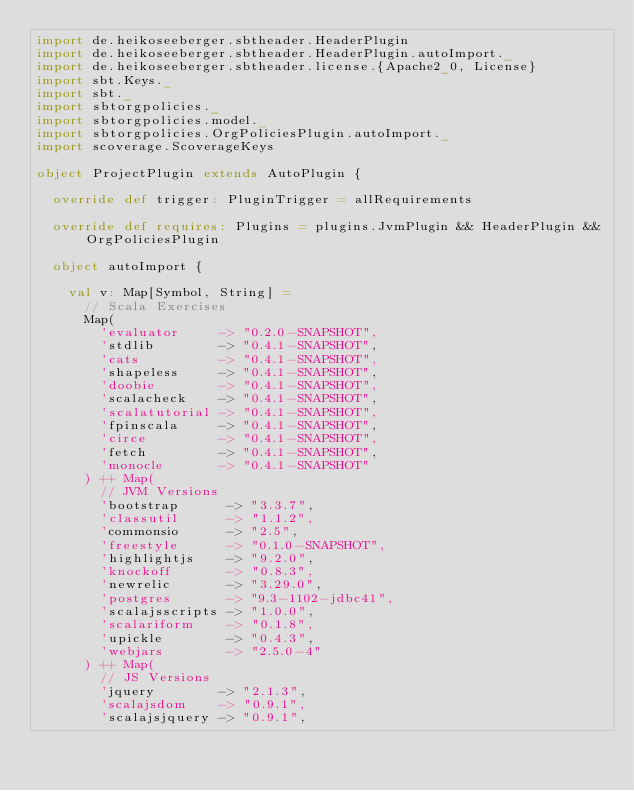<code> <loc_0><loc_0><loc_500><loc_500><_Scala_>import de.heikoseeberger.sbtheader.HeaderPlugin
import de.heikoseeberger.sbtheader.HeaderPlugin.autoImport._
import de.heikoseeberger.sbtheader.license.{Apache2_0, License}
import sbt.Keys._
import sbt._
import sbtorgpolicies._
import sbtorgpolicies.model._
import sbtorgpolicies.OrgPoliciesPlugin.autoImport._
import scoverage.ScoverageKeys

object ProjectPlugin extends AutoPlugin {

  override def trigger: PluginTrigger = allRequirements

  override def requires: Plugins = plugins.JvmPlugin && HeaderPlugin && OrgPoliciesPlugin

  object autoImport {

    val v: Map[Symbol, String] =
      // Scala Exercises
      Map(
        'evaluator     -> "0.2.0-SNAPSHOT",
        'stdlib        -> "0.4.1-SNAPSHOT",
        'cats          -> "0.4.1-SNAPSHOT",
        'shapeless     -> "0.4.1-SNAPSHOT",
        'doobie        -> "0.4.1-SNAPSHOT",
        'scalacheck    -> "0.4.1-SNAPSHOT",
        'scalatutorial -> "0.4.1-SNAPSHOT",
        'fpinscala     -> "0.4.1-SNAPSHOT",
        'circe         -> "0.4.1-SNAPSHOT",
        'fetch         -> "0.4.1-SNAPSHOT",
        'monocle       -> "0.4.1-SNAPSHOT"
      ) ++ Map(
        // JVM Versions
        'bootstrap      -> "3.3.7",
        'classutil      -> "1.1.2",
        'commonsio      -> "2.5",
        'freestyle      -> "0.1.0-SNAPSHOT",
        'highlightjs    -> "9.2.0",
        'knockoff       -> "0.8.3",
        'newrelic       -> "3.29.0",
        'postgres       -> "9.3-1102-jdbc41",
        'scalajsscripts -> "1.0.0",
        'scalariform    -> "0.1.8",
        'upickle        -> "0.4.3",
        'webjars        -> "2.5.0-4"
      ) ++ Map(
        // JS Versions
        'jquery        -> "2.1.3",
        'scalajsdom    -> "0.9.1",
        'scalajsjquery -> "0.9.1",</code> 